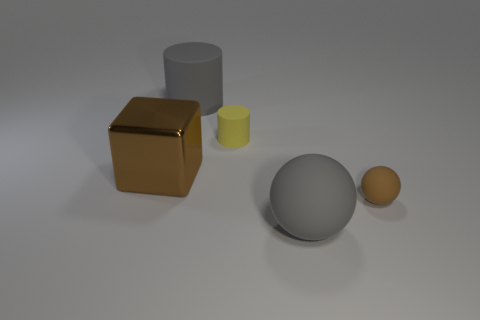Is there anything else that is made of the same material as the cube?
Ensure brevity in your answer.  No. Is the number of things behind the small sphere the same as the number of large objects?
Ensure brevity in your answer.  Yes. There is a gray matte thing behind the gray rubber ball; how big is it?
Keep it short and to the point. Large. What number of tiny objects are either brown shiny objects or gray things?
Provide a short and direct response. 0. What is the color of the big matte object that is the same shape as the tiny brown thing?
Your answer should be very brief. Gray. Do the brown block and the gray matte cylinder have the same size?
Keep it short and to the point. Yes. How many objects are small purple rubber spheres or gray rubber objects that are behind the yellow object?
Provide a short and direct response. 1. The small thing that is behind the brown thing on the left side of the brown ball is what color?
Keep it short and to the point. Yellow. Is the color of the big matte thing that is behind the metal cube the same as the big ball?
Your response must be concise. Yes. What material is the brown thing on the left side of the large rubber ball?
Offer a terse response. Metal. 